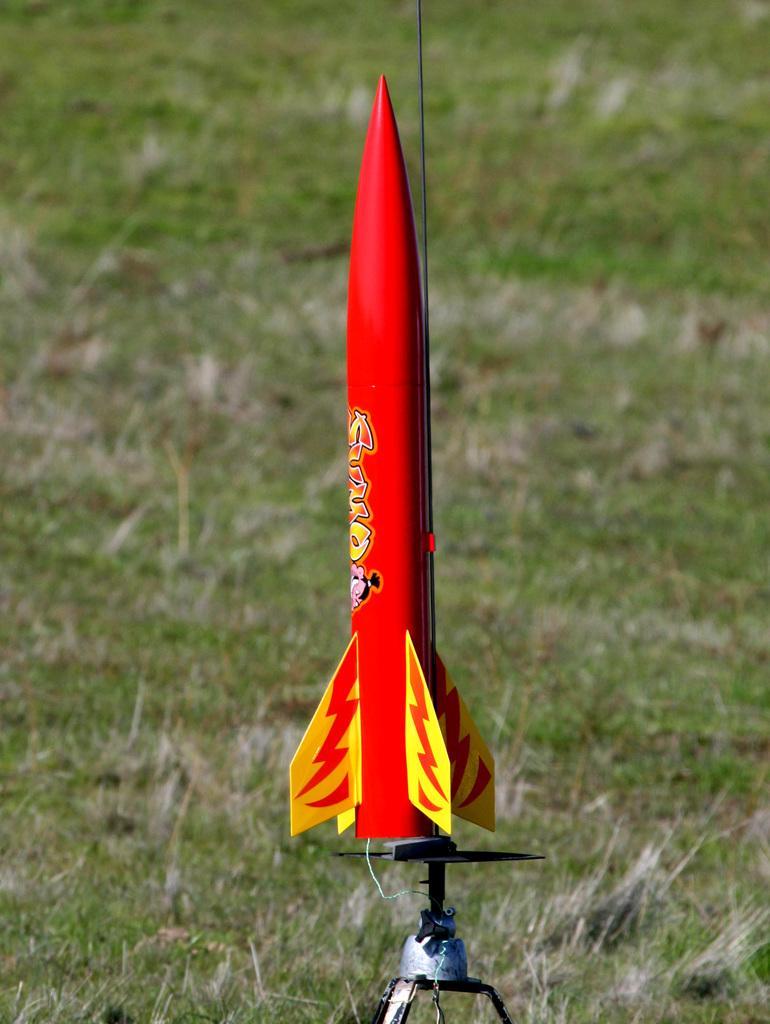Please provide a concise description of this image. In the image there is a toy rocket in the middle of the grassland. 